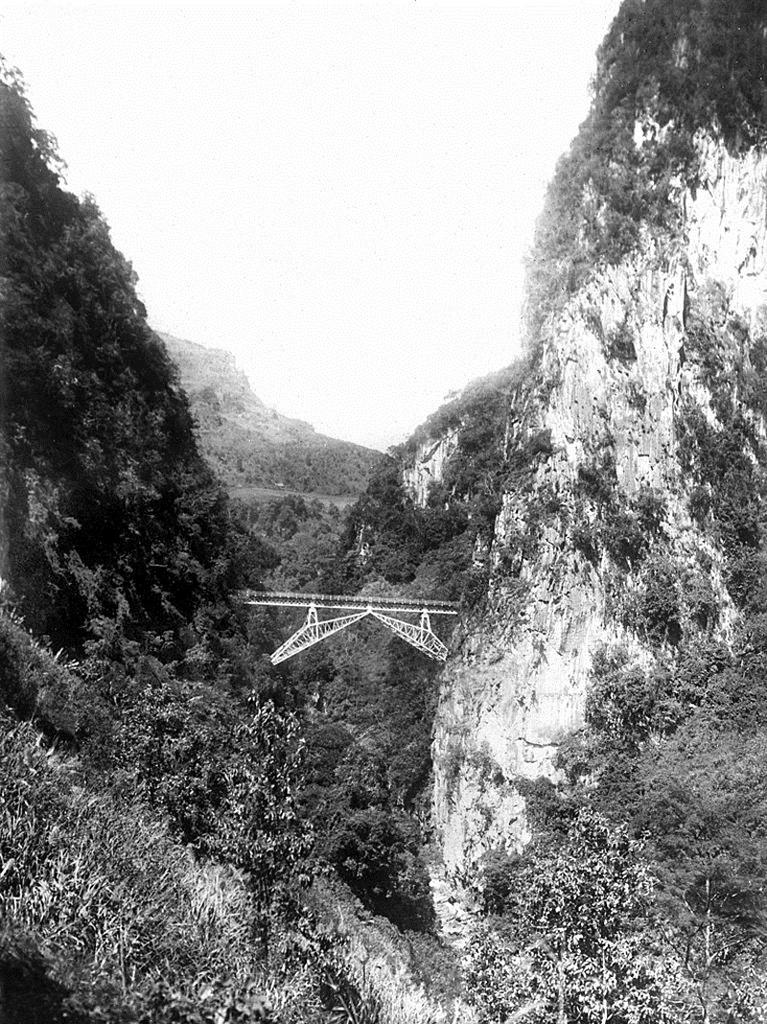Where was the picture taken? The picture was clicked outside. What can be seen in the center of the image? There is an object in the air in the center of the image. What type of natural elements are visible in the image? Trees, plants, and rocks are visible in the image. What is visible in the background of the image? The sky is visible in the background of the image. What type of amusement can be seen in the image? There is no amusement present in the image. Can you tell me how many coils are visible in the image? There is no coil present in the image. 